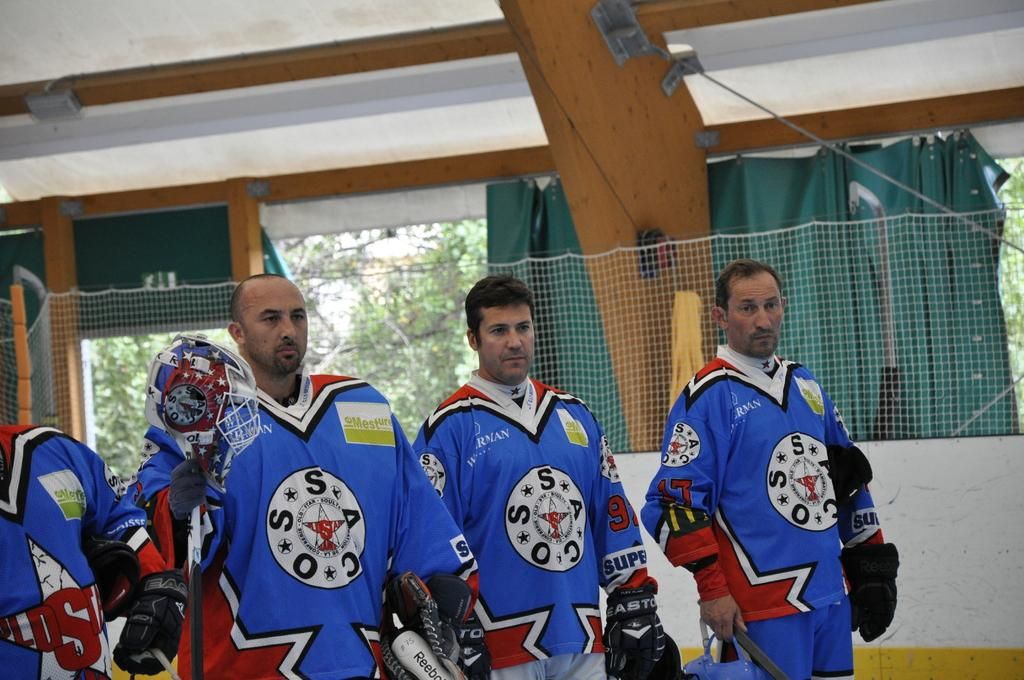<image>
Create a compact narrative representing the image presented. A hockey team wearing Easton gloves with SACOS on the front. 